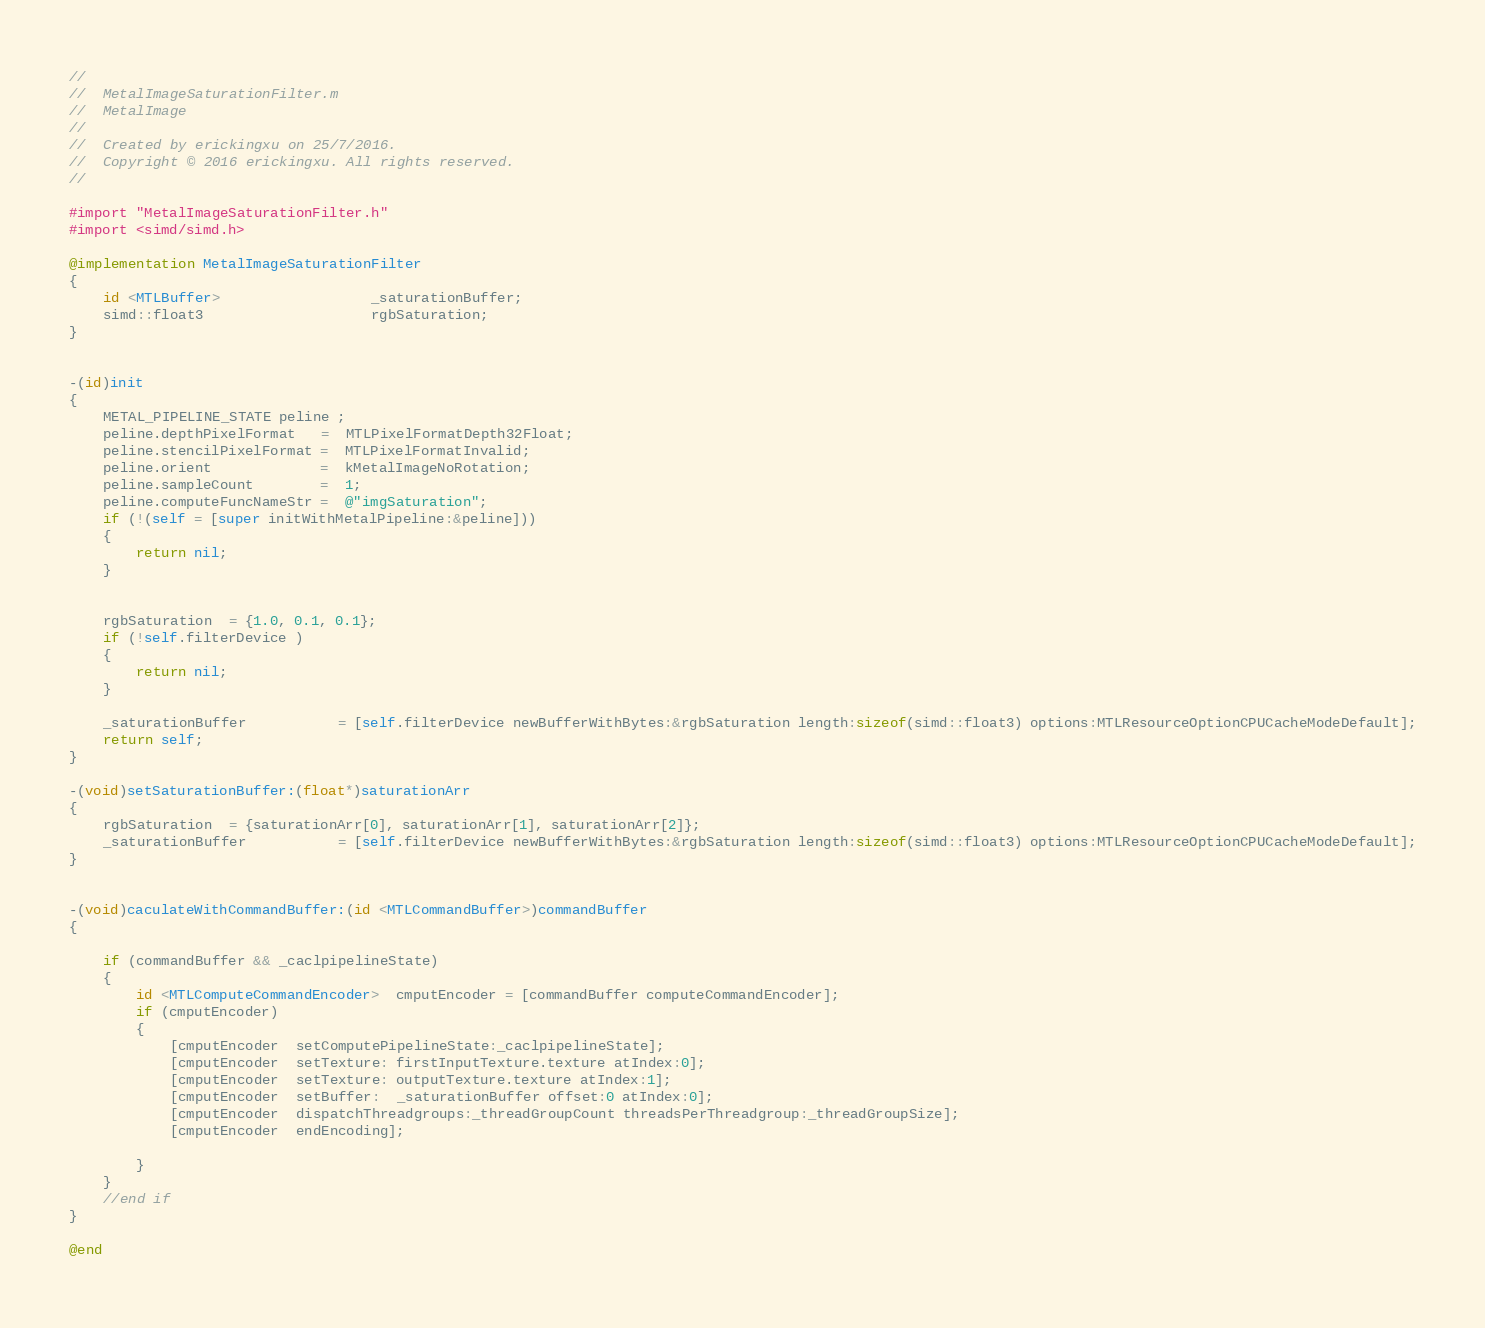Convert code to text. <code><loc_0><loc_0><loc_500><loc_500><_ObjectiveC_>//
//  MetalImageSaturationFilter.m
//  MetalImage
//
//  Created by erickingxu on 25/7/2016.
//  Copyright © 2016 erickingxu. All rights reserved.
//

#import "MetalImageSaturationFilter.h"
#import <simd/simd.h>

@implementation MetalImageSaturationFilter
{
    id <MTLBuffer>                  _saturationBuffer;
    simd::float3                    rgbSaturation;
}


-(id)init
{
    METAL_PIPELINE_STATE peline ;
    peline.depthPixelFormat   =  MTLPixelFormatDepth32Float;
    peline.stencilPixelFormat =  MTLPixelFormatInvalid;
    peline.orient             =  kMetalImageNoRotation;
    peline.sampleCount        =  1;
    peline.computeFuncNameStr =  @"imgSaturation";
    if (!(self = [super initWithMetalPipeline:&peline]))
    {
        return nil;
    }
    
    
    rgbSaturation  = {1.0, 0.1, 0.1};
    if (!self.filterDevice )
    {
        return nil;
    }
    
    _saturationBuffer           = [self.filterDevice newBufferWithBytes:&rgbSaturation length:sizeof(simd::float3) options:MTLResourceOptionCPUCacheModeDefault];
    return self;
}

-(void)setSaturationBuffer:(float*)saturationArr
{
    rgbSaturation  = {saturationArr[0], saturationArr[1], saturationArr[2]};
    _saturationBuffer           = [self.filterDevice newBufferWithBytes:&rgbSaturation length:sizeof(simd::float3) options:MTLResourceOptionCPUCacheModeDefault];
}


-(void)caculateWithCommandBuffer:(id <MTLCommandBuffer>)commandBuffer
{
    
    if (commandBuffer && _caclpipelineState)
    {
        id <MTLComputeCommandEncoder>  cmputEncoder = [commandBuffer computeCommandEncoder];
        if (cmputEncoder)
        {
            [cmputEncoder  setComputePipelineState:_caclpipelineState];
            [cmputEncoder  setTexture: firstInputTexture.texture atIndex:0];
            [cmputEncoder  setTexture: outputTexture.texture atIndex:1];
            [cmputEncoder  setBuffer:  _saturationBuffer offset:0 atIndex:0];
            [cmputEncoder  dispatchThreadgroups:_threadGroupCount threadsPerThreadgroup:_threadGroupSize];
            [cmputEncoder  endEncoding];
            
        }
    }
    //end if
}

@end
</code> 